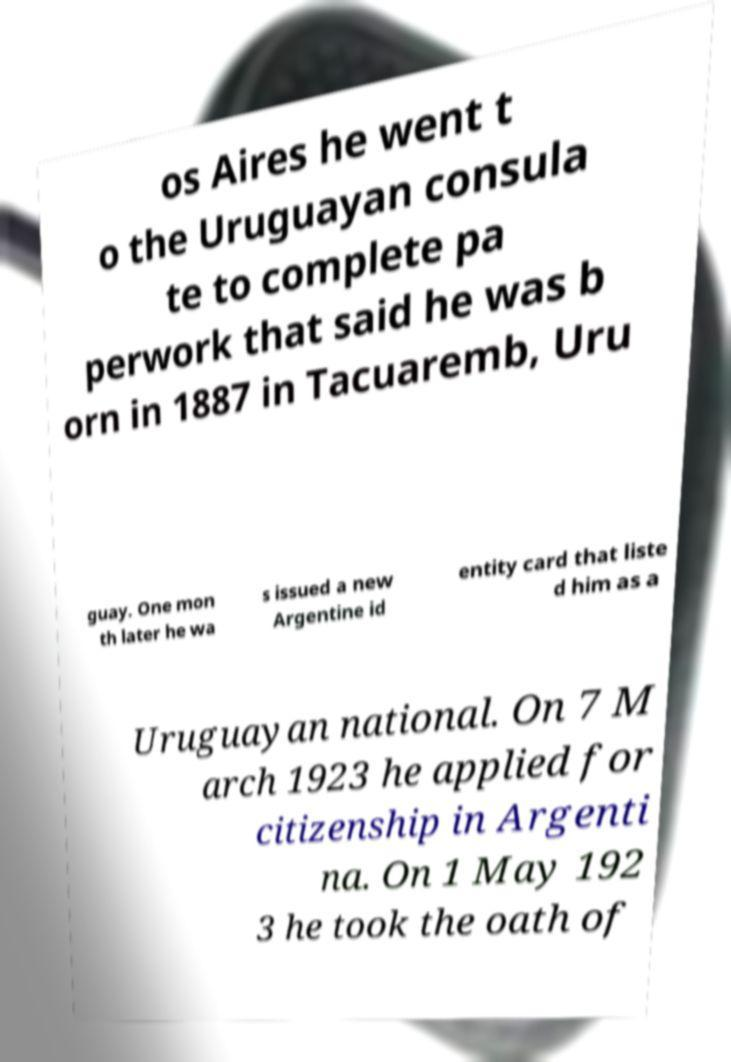There's text embedded in this image that I need extracted. Can you transcribe it verbatim? os Aires he went t o the Uruguayan consula te to complete pa perwork that said he was b orn in 1887 in Tacuaremb, Uru guay. One mon th later he wa s issued a new Argentine id entity card that liste d him as a Uruguayan national. On 7 M arch 1923 he applied for citizenship in Argenti na. On 1 May 192 3 he took the oath of 